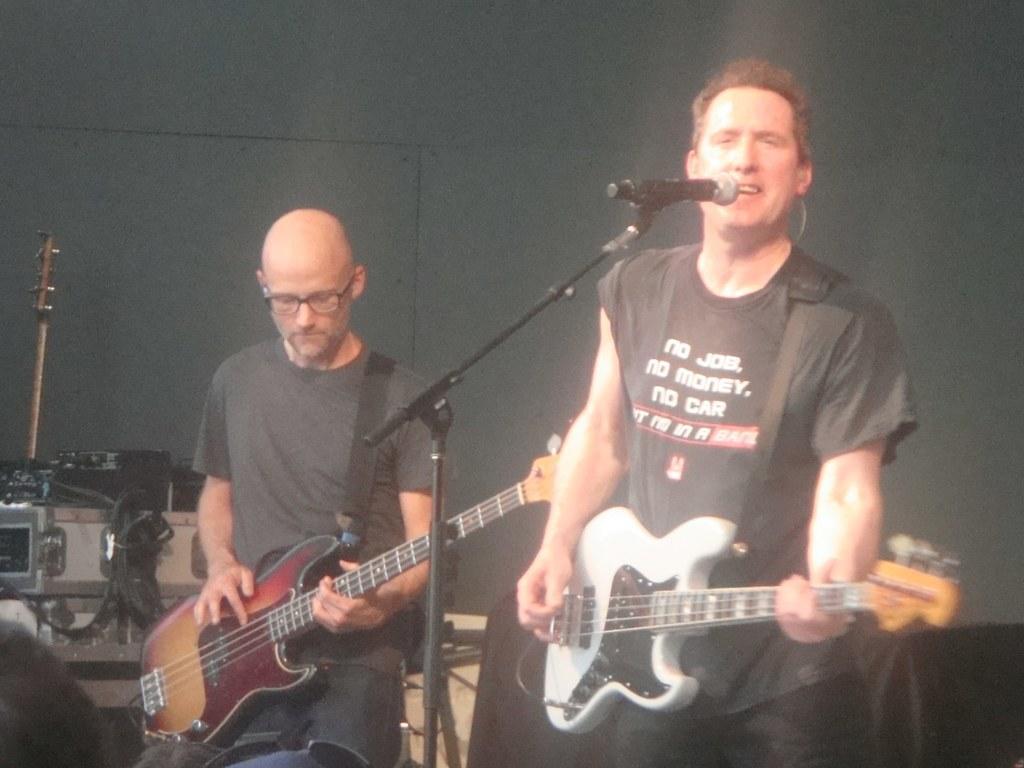Could you give a brief overview of what you see in this image? In this picture there are two persons standing and playing the guitar. One person is singing, he has a microphone in front of him. This person is holding the guitar in his left hand and playing the guitar with his right hand 